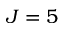Convert formula to latex. <formula><loc_0><loc_0><loc_500><loc_500>J = 5</formula> 